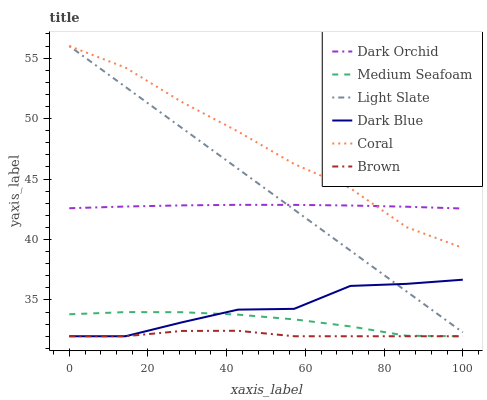Does Brown have the minimum area under the curve?
Answer yes or no. Yes. Does Coral have the maximum area under the curve?
Answer yes or no. Yes. Does Light Slate have the minimum area under the curve?
Answer yes or no. No. Does Light Slate have the maximum area under the curve?
Answer yes or no. No. Is Light Slate the smoothest?
Answer yes or no. Yes. Is Dark Blue the roughest?
Answer yes or no. Yes. Is Coral the smoothest?
Answer yes or no. No. Is Coral the roughest?
Answer yes or no. No. Does Brown have the lowest value?
Answer yes or no. Yes. Does Light Slate have the lowest value?
Answer yes or no. No. Does Coral have the highest value?
Answer yes or no. Yes. Does Dark Orchid have the highest value?
Answer yes or no. No. Is Dark Blue less than Coral?
Answer yes or no. Yes. Is Light Slate greater than Brown?
Answer yes or no. Yes. Does Brown intersect Medium Seafoam?
Answer yes or no. Yes. Is Brown less than Medium Seafoam?
Answer yes or no. No. Is Brown greater than Medium Seafoam?
Answer yes or no. No. Does Dark Blue intersect Coral?
Answer yes or no. No. 